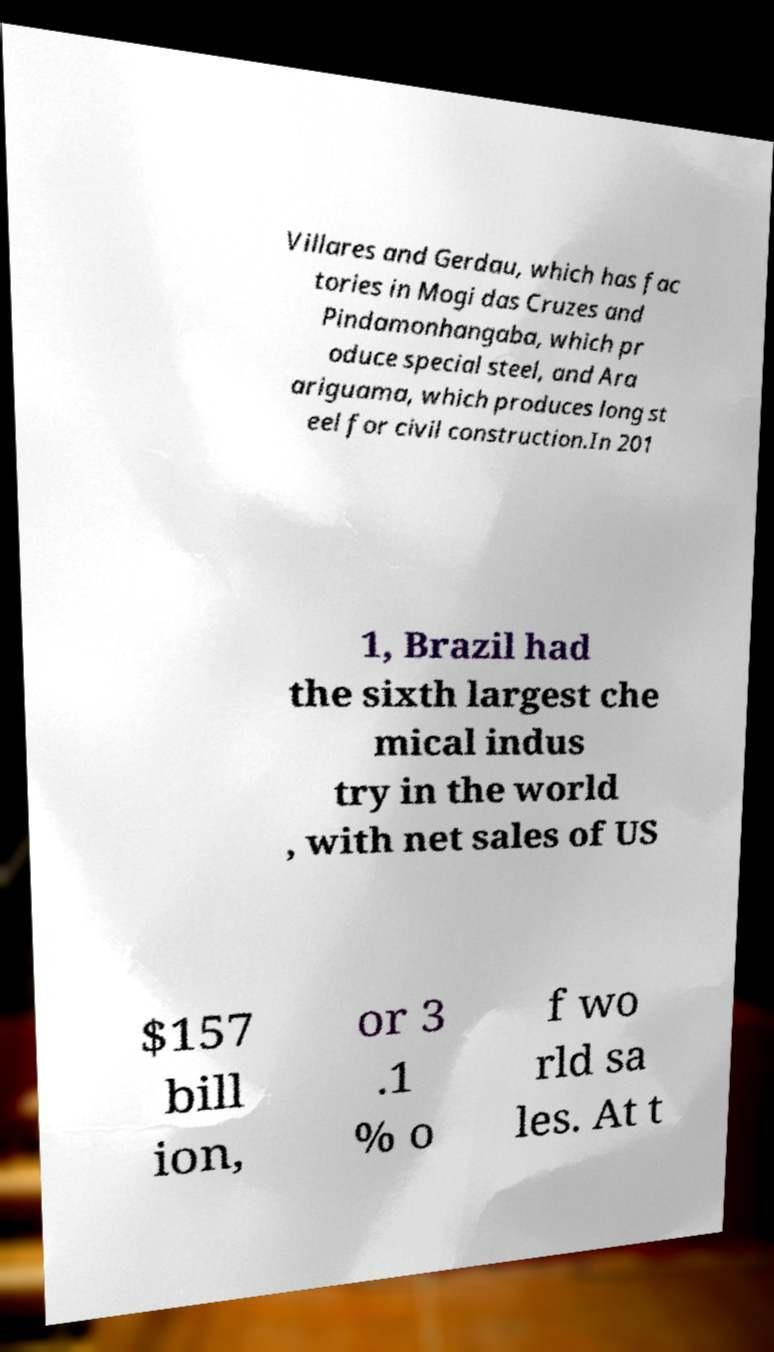Please read and relay the text visible in this image. What does it say? Villares and Gerdau, which has fac tories in Mogi das Cruzes and Pindamonhangaba, which pr oduce special steel, and Ara ariguama, which produces long st eel for civil construction.In 201 1, Brazil had the sixth largest che mical indus try in the world , with net sales of US $157 bill ion, or 3 .1 % o f wo rld sa les. At t 